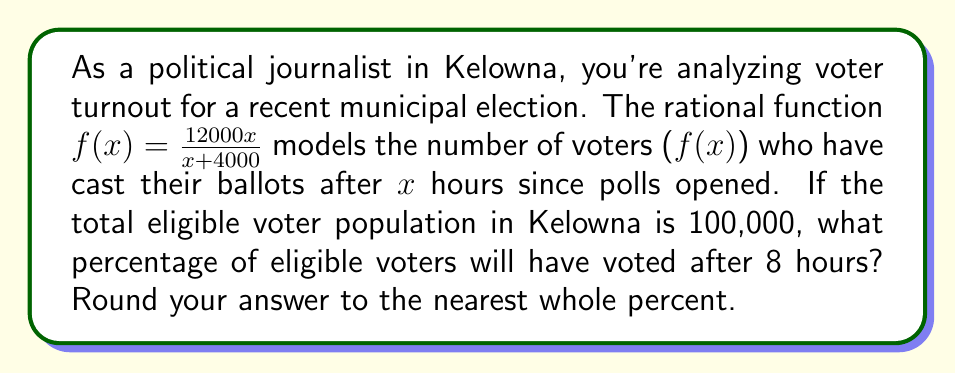What is the answer to this math problem? To solve this problem, we'll follow these steps:

1) First, let's calculate the number of voters after 8 hours by plugging x = 8 into our function:

   $$f(8) = \frac{12000(8)}{8+4000} = \frac{96000}{4008} \approx 23,952.10$$

2) This means that after 8 hours, approximately 23,952 people will have voted.

3) To calculate the percentage, we need to divide this by the total eligible voter population and multiply by 100:

   $$\text{Percentage} = \frac{\text{Number of voters}}{\text{Total eligible voters}} \times 100$$

   $$\text{Percentage} = \frac{23,952.10}{100,000} \times 100 \approx 23.95\%$$

4) Rounding to the nearest whole percent gives us 24%.
Answer: 24% 